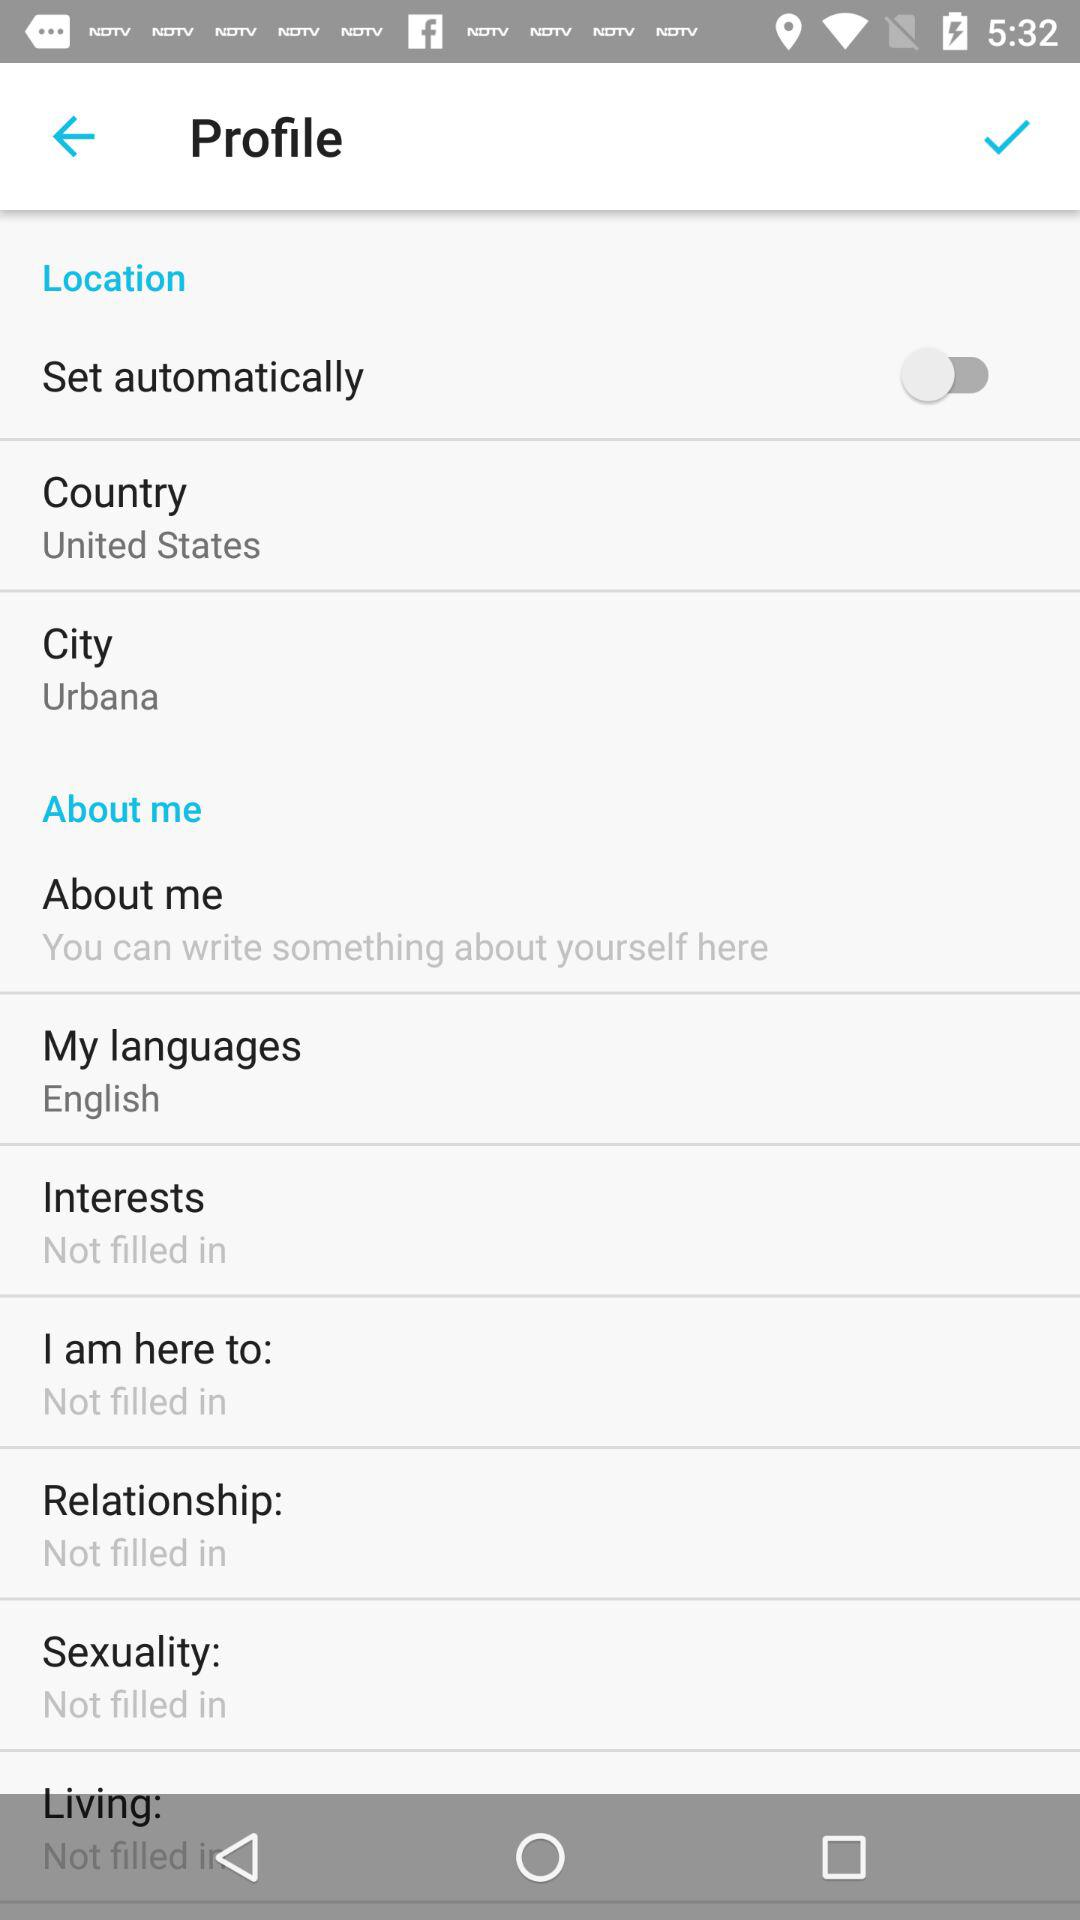What language is selected? The selected language is English. 